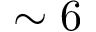Convert formula to latex. <formula><loc_0><loc_0><loc_500><loc_500>\sim 6</formula> 